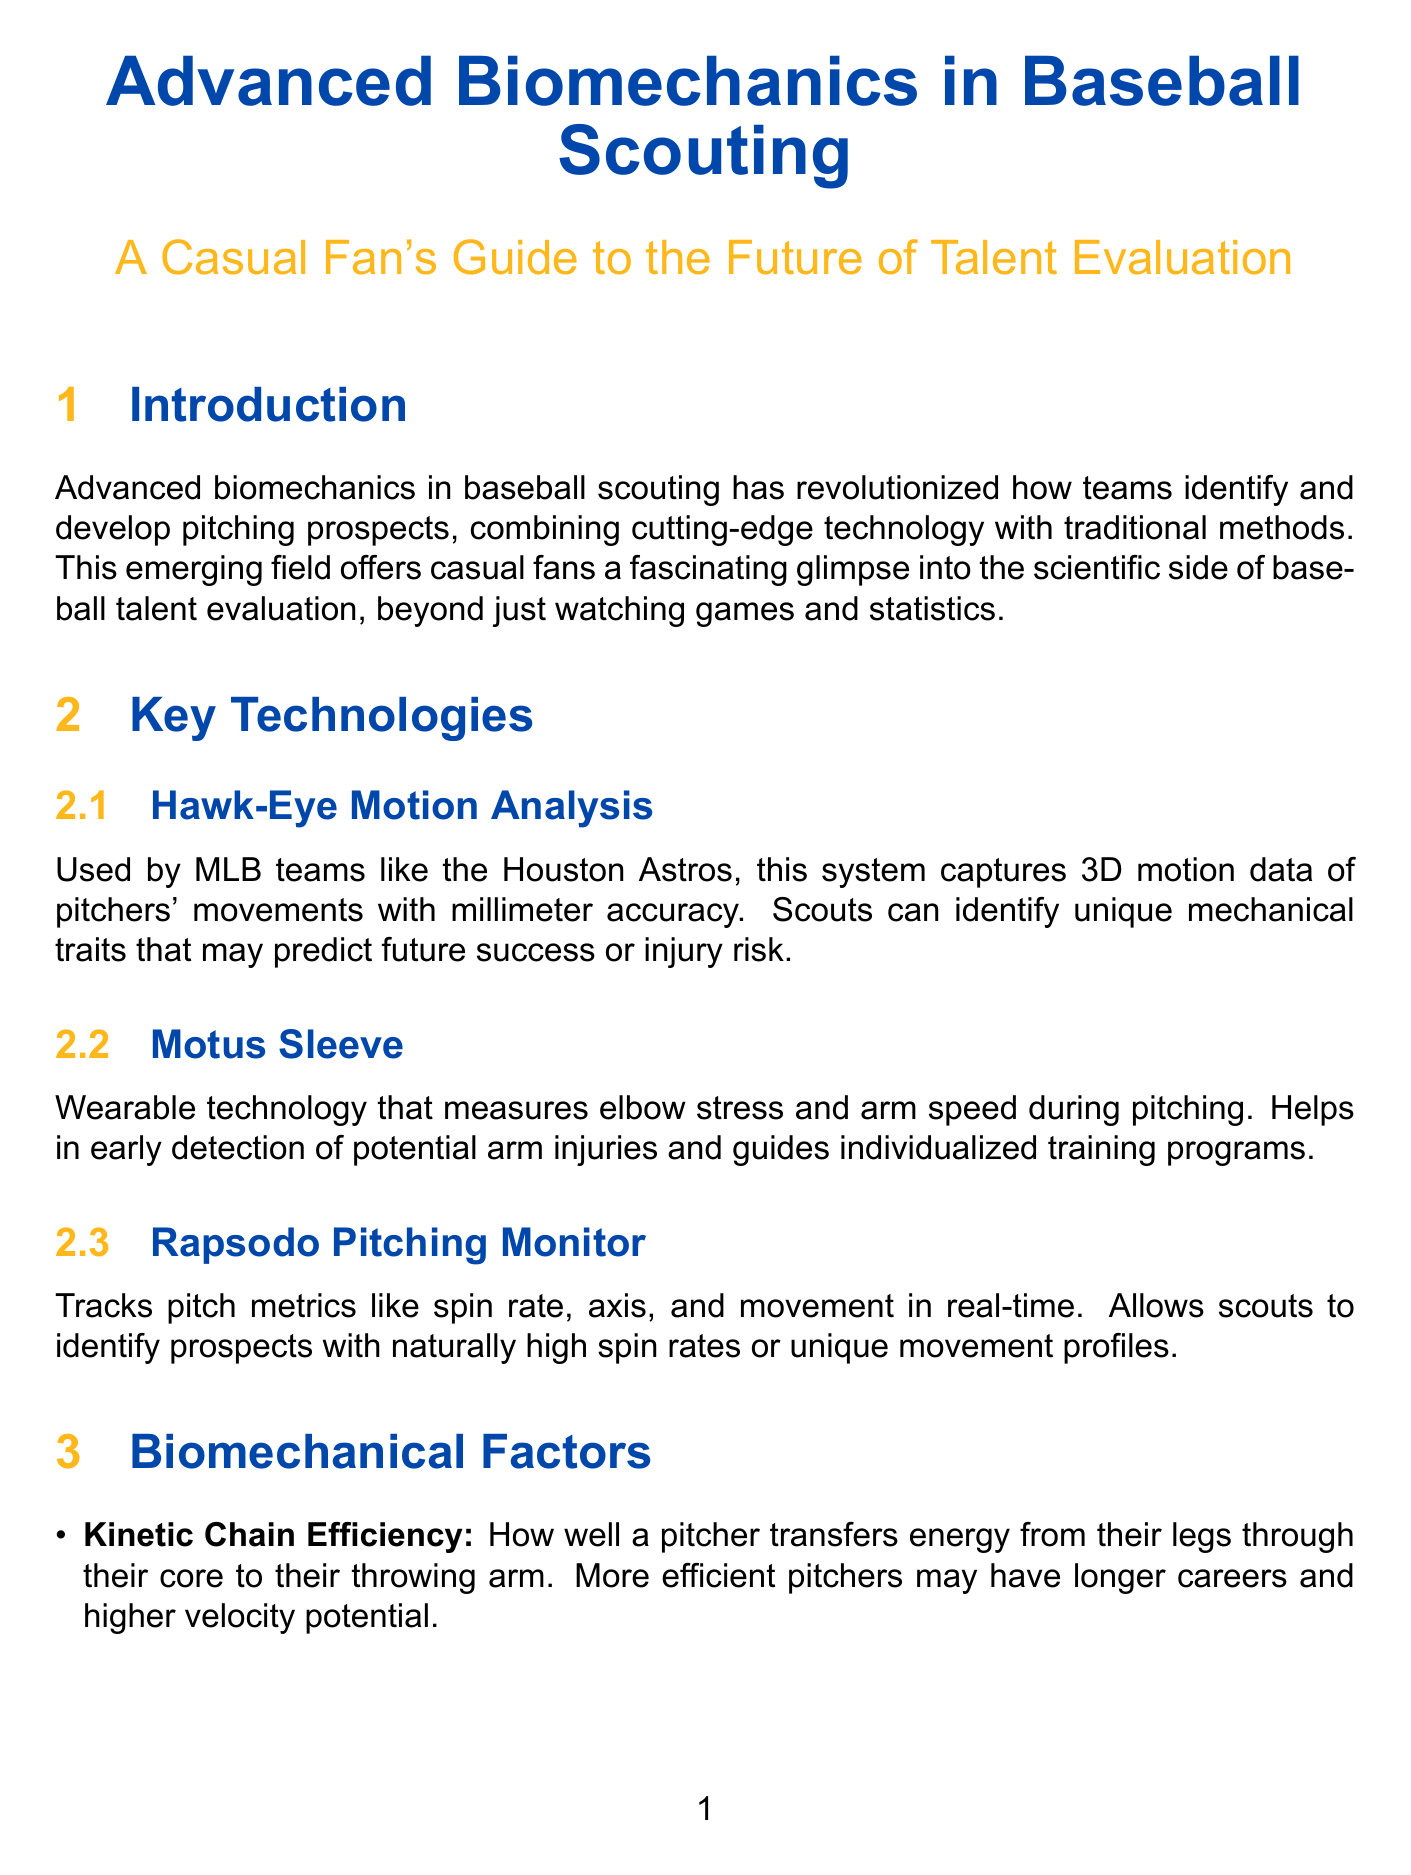What is the main focus of the introduction? The introduction discusses how advanced biomechanics is revolutionizing baseball scouting and talent evaluation methods.
Answer: Talent evaluation What technology is used by MLB teams like the Houston Astros? Hawk-Eye Motion Analysis captures 3D motion data of pitchers' movements.
Answer: Hawk-Eye Motion Analysis What biomechanical factor correlates with higher velocity? Shoulder External Rotation is associated with higher velocity.
Answer: Shoulder External Rotation Which team has one of the lowest pitcher injury rates in MLB? The Tampa Bay Rays have a notably low pitcher injury rate attributed to their advanced biomechanics program.
Answer: Tampa Bay Rays What is a potential impact of AI-powered scouting? AI-powered scouting could revolutionize how teams draft and develop pitchers.
Answer: Revolutionize drafting Who is identified as a top prospect due to biomechanics? Stephen Strasburg was recognized partly for his exceptional biomechanics.
Answer: Stephen Strasburg What wearable technology helps detect arm injuries? The Motus Sleeve is used to measure elbow stress and arm speed during pitching.
Answer: Motus Sleeve What is one method used for injury prevention mentioned in the document? Customized strengthening programs based on individual biomechanical profiles are one method.
Answer: Customized strengthening programs What aspect of the fan experience does the document highlight? The document mentions baseball camps featuring biomechanical analysis as a fan engagement opportunity.
Answer: Baseball camps What is a future trend in baseball training? Virtual reality training is identified as a future trend in helping pitchers visualize optimal biomechanics.
Answer: Virtual reality training 